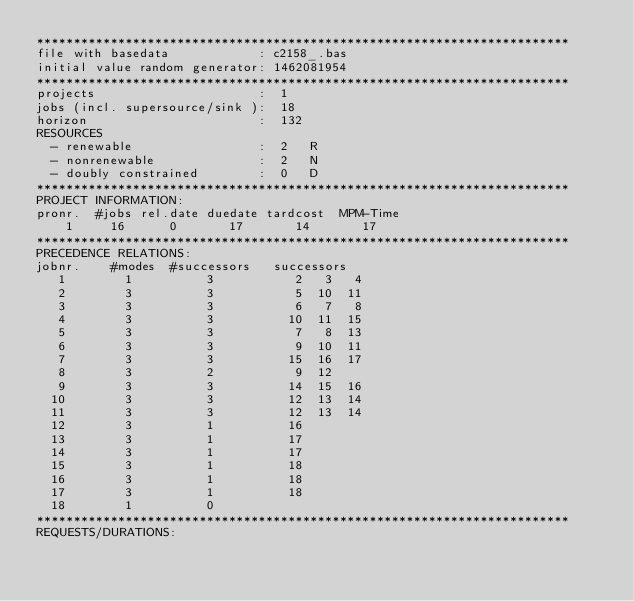<code> <loc_0><loc_0><loc_500><loc_500><_ObjectiveC_>************************************************************************
file with basedata            : c2158_.bas
initial value random generator: 1462081954
************************************************************************
projects                      :  1
jobs (incl. supersource/sink ):  18
horizon                       :  132
RESOURCES
  - renewable                 :  2   R
  - nonrenewable              :  2   N
  - doubly constrained        :  0   D
************************************************************************
PROJECT INFORMATION:
pronr.  #jobs rel.date duedate tardcost  MPM-Time
    1     16      0       17       14       17
************************************************************************
PRECEDENCE RELATIONS:
jobnr.    #modes  #successors   successors
   1        1          3           2   3   4
   2        3          3           5  10  11
   3        3          3           6   7   8
   4        3          3          10  11  15
   5        3          3           7   8  13
   6        3          3           9  10  11
   7        3          3          15  16  17
   8        3          2           9  12
   9        3          3          14  15  16
  10        3          3          12  13  14
  11        3          3          12  13  14
  12        3          1          16
  13        3          1          17
  14        3          1          17
  15        3          1          18
  16        3          1          18
  17        3          1          18
  18        1          0        
************************************************************************
REQUESTS/DURATIONS:</code> 